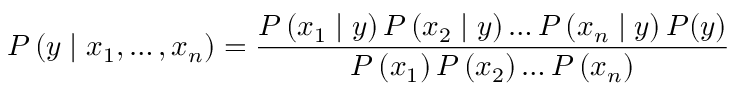<formula> <loc_0><loc_0><loc_500><loc_500>P \left ( y | x _ { 1 } , \dots , x _ { n } \right ) = \frac { P \left ( x _ { 1 } | y \right ) P \left ( x _ { 2 } | y \right ) \dots P \left ( x _ { n } | y \right ) P ( y ) } { P \left ( x _ { 1 } \right ) P \left ( x _ { 2 } \right ) \dots P \left ( x _ { n } \right ) }</formula> 